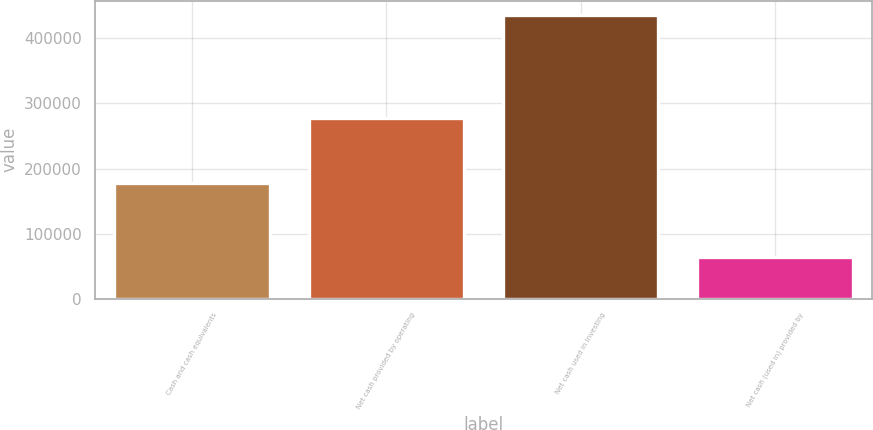<chart> <loc_0><loc_0><loc_500><loc_500><bar_chart><fcel>Cash and cash equivalents<fcel>Net cash provided by operating<fcel>Net cash used in investing<fcel>Net cash (used in) provided by<nl><fcel>177439<fcel>277424<fcel>436024<fcel>64391<nl></chart> 